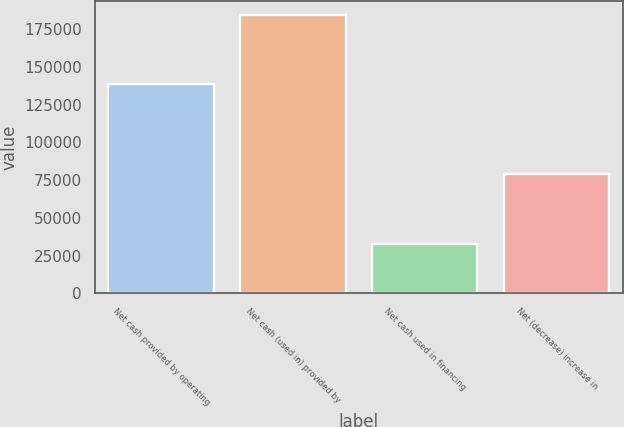Convert chart. <chart><loc_0><loc_0><loc_500><loc_500><bar_chart><fcel>Net cash provided by operating<fcel>Net cash (used in) provided by<fcel>Net cash used in financing<fcel>Net (decrease) increase in<nl><fcel>138459<fcel>184457<fcel>32797<fcel>78795<nl></chart> 